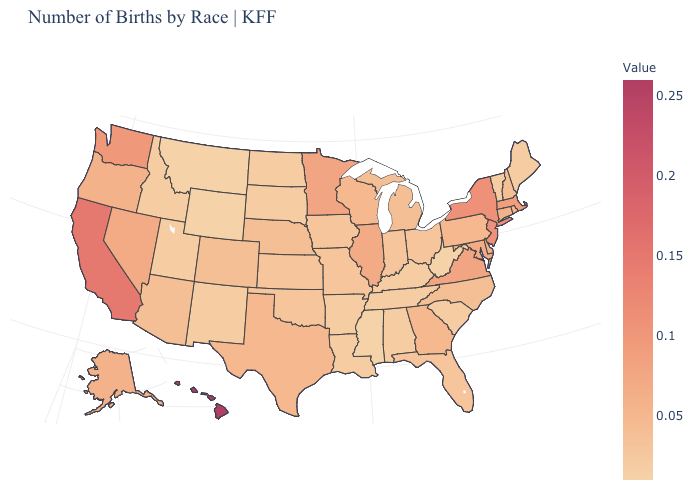Is the legend a continuous bar?
Concise answer only. Yes. Which states have the highest value in the USA?
Keep it brief. Hawaii. Which states have the highest value in the USA?
Write a very short answer. Hawaii. Is the legend a continuous bar?
Answer briefly. Yes. Does Idaho have a higher value than Wisconsin?
Concise answer only. No. Among the states that border Oklahoma , does Arkansas have the lowest value?
Short answer required. Yes. Which states have the lowest value in the Northeast?
Give a very brief answer. Maine, Vermont. Is the legend a continuous bar?
Quick response, please. Yes. Which states have the lowest value in the West?
Answer briefly. Montana, Wyoming. 